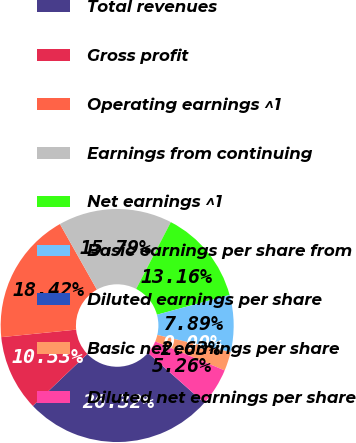<chart> <loc_0><loc_0><loc_500><loc_500><pie_chart><fcel>Total revenues<fcel>Gross profit<fcel>Operating earnings ^1<fcel>Earnings from continuing<fcel>Net earnings ^1<fcel>Basic earnings per share from<fcel>Diluted earnings per share<fcel>Basic net earnings per share<fcel>Diluted net earnings per share<nl><fcel>26.32%<fcel>10.53%<fcel>18.42%<fcel>15.79%<fcel>13.16%<fcel>7.89%<fcel>0.0%<fcel>2.63%<fcel>5.26%<nl></chart> 